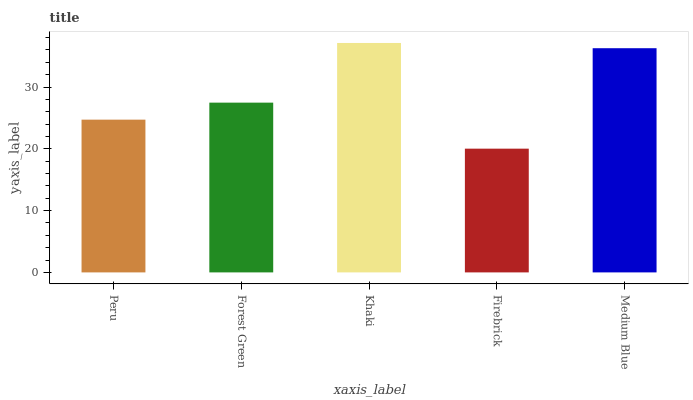Is Khaki the maximum?
Answer yes or no. Yes. Is Forest Green the minimum?
Answer yes or no. No. Is Forest Green the maximum?
Answer yes or no. No. Is Forest Green greater than Peru?
Answer yes or no. Yes. Is Peru less than Forest Green?
Answer yes or no. Yes. Is Peru greater than Forest Green?
Answer yes or no. No. Is Forest Green less than Peru?
Answer yes or no. No. Is Forest Green the high median?
Answer yes or no. Yes. Is Forest Green the low median?
Answer yes or no. Yes. Is Peru the high median?
Answer yes or no. No. Is Medium Blue the low median?
Answer yes or no. No. 